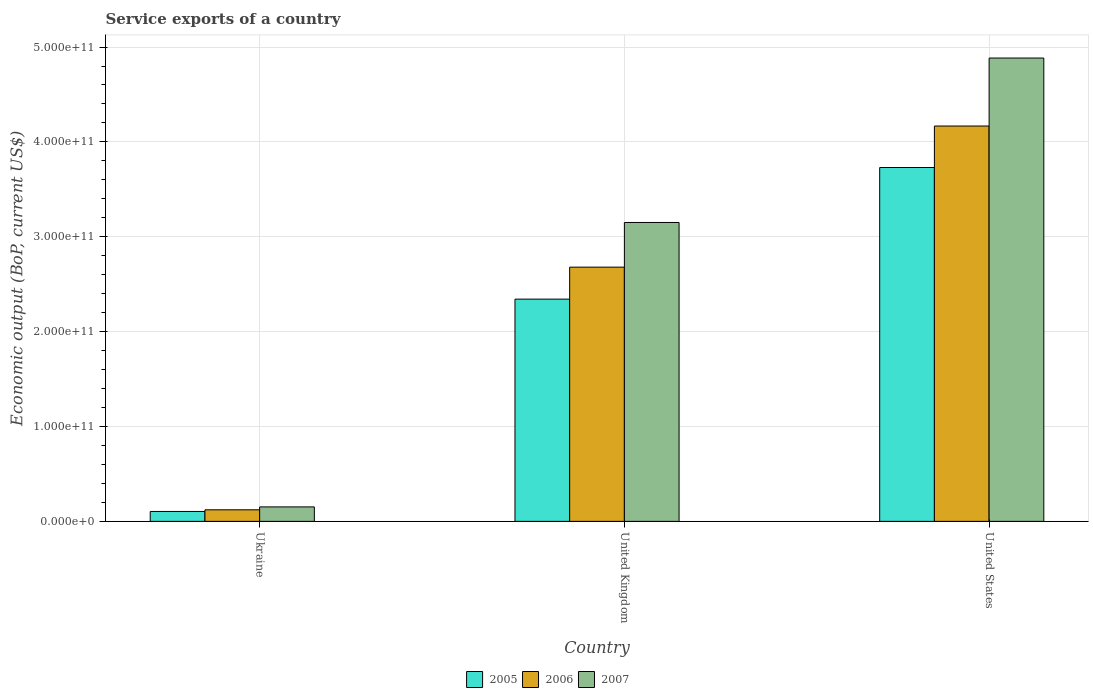How many different coloured bars are there?
Keep it short and to the point. 3. How many bars are there on the 1st tick from the left?
Your answer should be compact. 3. How many bars are there on the 3rd tick from the right?
Provide a short and direct response. 3. What is the label of the 1st group of bars from the left?
Keep it short and to the point. Ukraine. In how many cases, is the number of bars for a given country not equal to the number of legend labels?
Provide a short and direct response. 0. What is the service exports in 2005 in Ukraine?
Make the answer very short. 1.04e+1. Across all countries, what is the maximum service exports in 2005?
Ensure brevity in your answer.  3.73e+11. Across all countries, what is the minimum service exports in 2007?
Your answer should be very brief. 1.52e+1. In which country was the service exports in 2007 maximum?
Provide a succinct answer. United States. In which country was the service exports in 2007 minimum?
Offer a terse response. Ukraine. What is the total service exports in 2006 in the graph?
Provide a short and direct response. 6.97e+11. What is the difference between the service exports in 2007 in United Kingdom and that in United States?
Give a very brief answer. -1.73e+11. What is the difference between the service exports in 2006 in Ukraine and the service exports in 2007 in United States?
Your answer should be compact. -4.76e+11. What is the average service exports in 2007 per country?
Your response must be concise. 2.73e+11. What is the difference between the service exports of/in 2007 and service exports of/in 2005 in United Kingdom?
Your answer should be very brief. 8.08e+1. In how many countries, is the service exports in 2006 greater than 280000000000 US$?
Provide a short and direct response. 1. What is the ratio of the service exports in 2005 in Ukraine to that in United States?
Offer a terse response. 0.03. Is the service exports in 2006 in Ukraine less than that in United Kingdom?
Offer a terse response. Yes. Is the difference between the service exports in 2007 in United Kingdom and United States greater than the difference between the service exports in 2005 in United Kingdom and United States?
Keep it short and to the point. No. What is the difference between the highest and the second highest service exports in 2005?
Ensure brevity in your answer.  3.63e+11. What is the difference between the highest and the lowest service exports in 2006?
Your answer should be compact. 4.05e+11. In how many countries, is the service exports in 2005 greater than the average service exports in 2005 taken over all countries?
Ensure brevity in your answer.  2. What does the 2nd bar from the left in United States represents?
Your response must be concise. 2006. What does the 3rd bar from the right in Ukraine represents?
Keep it short and to the point. 2005. Is it the case that in every country, the sum of the service exports in 2006 and service exports in 2007 is greater than the service exports in 2005?
Keep it short and to the point. Yes. What is the difference between two consecutive major ticks on the Y-axis?
Provide a succinct answer. 1.00e+11. Does the graph contain any zero values?
Your response must be concise. No. How are the legend labels stacked?
Your answer should be compact. Horizontal. What is the title of the graph?
Your response must be concise. Service exports of a country. Does "2000" appear as one of the legend labels in the graph?
Ensure brevity in your answer.  No. What is the label or title of the X-axis?
Keep it short and to the point. Country. What is the label or title of the Y-axis?
Give a very brief answer. Economic output (BoP, current US$). What is the Economic output (BoP, current US$) of 2005 in Ukraine?
Offer a very short reply. 1.04e+1. What is the Economic output (BoP, current US$) in 2006 in Ukraine?
Your answer should be very brief. 1.22e+1. What is the Economic output (BoP, current US$) of 2007 in Ukraine?
Ensure brevity in your answer.  1.52e+1. What is the Economic output (BoP, current US$) of 2005 in United Kingdom?
Give a very brief answer. 2.34e+11. What is the Economic output (BoP, current US$) in 2006 in United Kingdom?
Ensure brevity in your answer.  2.68e+11. What is the Economic output (BoP, current US$) in 2007 in United Kingdom?
Ensure brevity in your answer.  3.15e+11. What is the Economic output (BoP, current US$) of 2005 in United States?
Ensure brevity in your answer.  3.73e+11. What is the Economic output (BoP, current US$) of 2006 in United States?
Your response must be concise. 4.17e+11. What is the Economic output (BoP, current US$) of 2007 in United States?
Give a very brief answer. 4.88e+11. Across all countries, what is the maximum Economic output (BoP, current US$) of 2005?
Make the answer very short. 3.73e+11. Across all countries, what is the maximum Economic output (BoP, current US$) of 2006?
Give a very brief answer. 4.17e+11. Across all countries, what is the maximum Economic output (BoP, current US$) of 2007?
Offer a very short reply. 4.88e+11. Across all countries, what is the minimum Economic output (BoP, current US$) of 2005?
Provide a succinct answer. 1.04e+1. Across all countries, what is the minimum Economic output (BoP, current US$) in 2006?
Provide a succinct answer. 1.22e+1. Across all countries, what is the minimum Economic output (BoP, current US$) in 2007?
Provide a short and direct response. 1.52e+1. What is the total Economic output (BoP, current US$) in 2005 in the graph?
Offer a terse response. 6.18e+11. What is the total Economic output (BoP, current US$) in 2006 in the graph?
Ensure brevity in your answer.  6.97e+11. What is the total Economic output (BoP, current US$) of 2007 in the graph?
Your answer should be very brief. 8.19e+11. What is the difference between the Economic output (BoP, current US$) of 2005 in Ukraine and that in United Kingdom?
Make the answer very short. -2.24e+11. What is the difference between the Economic output (BoP, current US$) in 2006 in Ukraine and that in United Kingdom?
Offer a very short reply. -2.56e+11. What is the difference between the Economic output (BoP, current US$) of 2007 in Ukraine and that in United Kingdom?
Keep it short and to the point. -3.00e+11. What is the difference between the Economic output (BoP, current US$) of 2005 in Ukraine and that in United States?
Your answer should be very brief. -3.63e+11. What is the difference between the Economic output (BoP, current US$) in 2006 in Ukraine and that in United States?
Offer a terse response. -4.05e+11. What is the difference between the Economic output (BoP, current US$) of 2007 in Ukraine and that in United States?
Your answer should be compact. -4.73e+11. What is the difference between the Economic output (BoP, current US$) of 2005 in United Kingdom and that in United States?
Provide a short and direct response. -1.39e+11. What is the difference between the Economic output (BoP, current US$) in 2006 in United Kingdom and that in United States?
Make the answer very short. -1.49e+11. What is the difference between the Economic output (BoP, current US$) of 2007 in United Kingdom and that in United States?
Provide a succinct answer. -1.73e+11. What is the difference between the Economic output (BoP, current US$) of 2005 in Ukraine and the Economic output (BoP, current US$) of 2006 in United Kingdom?
Make the answer very short. -2.58e+11. What is the difference between the Economic output (BoP, current US$) of 2005 in Ukraine and the Economic output (BoP, current US$) of 2007 in United Kingdom?
Offer a very short reply. -3.05e+11. What is the difference between the Economic output (BoP, current US$) of 2006 in Ukraine and the Economic output (BoP, current US$) of 2007 in United Kingdom?
Make the answer very short. -3.03e+11. What is the difference between the Economic output (BoP, current US$) in 2005 in Ukraine and the Economic output (BoP, current US$) in 2006 in United States?
Ensure brevity in your answer.  -4.06e+11. What is the difference between the Economic output (BoP, current US$) in 2005 in Ukraine and the Economic output (BoP, current US$) in 2007 in United States?
Offer a terse response. -4.78e+11. What is the difference between the Economic output (BoP, current US$) of 2006 in Ukraine and the Economic output (BoP, current US$) of 2007 in United States?
Your answer should be compact. -4.76e+11. What is the difference between the Economic output (BoP, current US$) in 2005 in United Kingdom and the Economic output (BoP, current US$) in 2006 in United States?
Give a very brief answer. -1.82e+11. What is the difference between the Economic output (BoP, current US$) of 2005 in United Kingdom and the Economic output (BoP, current US$) of 2007 in United States?
Offer a very short reply. -2.54e+11. What is the difference between the Economic output (BoP, current US$) in 2006 in United Kingdom and the Economic output (BoP, current US$) in 2007 in United States?
Provide a short and direct response. -2.20e+11. What is the average Economic output (BoP, current US$) in 2005 per country?
Ensure brevity in your answer.  2.06e+11. What is the average Economic output (BoP, current US$) in 2006 per country?
Ensure brevity in your answer.  2.32e+11. What is the average Economic output (BoP, current US$) in 2007 per country?
Offer a terse response. 2.73e+11. What is the difference between the Economic output (BoP, current US$) of 2005 and Economic output (BoP, current US$) of 2006 in Ukraine?
Your answer should be very brief. -1.74e+09. What is the difference between the Economic output (BoP, current US$) in 2005 and Economic output (BoP, current US$) in 2007 in Ukraine?
Offer a terse response. -4.80e+09. What is the difference between the Economic output (BoP, current US$) in 2006 and Economic output (BoP, current US$) in 2007 in Ukraine?
Your answer should be very brief. -3.06e+09. What is the difference between the Economic output (BoP, current US$) in 2005 and Economic output (BoP, current US$) in 2006 in United Kingdom?
Make the answer very short. -3.37e+1. What is the difference between the Economic output (BoP, current US$) in 2005 and Economic output (BoP, current US$) in 2007 in United Kingdom?
Give a very brief answer. -8.08e+1. What is the difference between the Economic output (BoP, current US$) in 2006 and Economic output (BoP, current US$) in 2007 in United Kingdom?
Your response must be concise. -4.71e+1. What is the difference between the Economic output (BoP, current US$) of 2005 and Economic output (BoP, current US$) of 2006 in United States?
Provide a succinct answer. -4.37e+1. What is the difference between the Economic output (BoP, current US$) in 2005 and Economic output (BoP, current US$) in 2007 in United States?
Offer a terse response. -1.15e+11. What is the difference between the Economic output (BoP, current US$) in 2006 and Economic output (BoP, current US$) in 2007 in United States?
Provide a short and direct response. -7.17e+1. What is the ratio of the Economic output (BoP, current US$) in 2005 in Ukraine to that in United Kingdom?
Provide a short and direct response. 0.04. What is the ratio of the Economic output (BoP, current US$) in 2006 in Ukraine to that in United Kingdom?
Keep it short and to the point. 0.05. What is the ratio of the Economic output (BoP, current US$) of 2007 in Ukraine to that in United Kingdom?
Make the answer very short. 0.05. What is the ratio of the Economic output (BoP, current US$) of 2005 in Ukraine to that in United States?
Keep it short and to the point. 0.03. What is the ratio of the Economic output (BoP, current US$) of 2006 in Ukraine to that in United States?
Make the answer very short. 0.03. What is the ratio of the Economic output (BoP, current US$) of 2007 in Ukraine to that in United States?
Your response must be concise. 0.03. What is the ratio of the Economic output (BoP, current US$) of 2005 in United Kingdom to that in United States?
Ensure brevity in your answer.  0.63. What is the ratio of the Economic output (BoP, current US$) in 2006 in United Kingdom to that in United States?
Provide a succinct answer. 0.64. What is the ratio of the Economic output (BoP, current US$) in 2007 in United Kingdom to that in United States?
Make the answer very short. 0.65. What is the difference between the highest and the second highest Economic output (BoP, current US$) of 2005?
Give a very brief answer. 1.39e+11. What is the difference between the highest and the second highest Economic output (BoP, current US$) in 2006?
Provide a short and direct response. 1.49e+11. What is the difference between the highest and the second highest Economic output (BoP, current US$) of 2007?
Ensure brevity in your answer.  1.73e+11. What is the difference between the highest and the lowest Economic output (BoP, current US$) of 2005?
Your answer should be compact. 3.63e+11. What is the difference between the highest and the lowest Economic output (BoP, current US$) of 2006?
Ensure brevity in your answer.  4.05e+11. What is the difference between the highest and the lowest Economic output (BoP, current US$) in 2007?
Provide a succinct answer. 4.73e+11. 